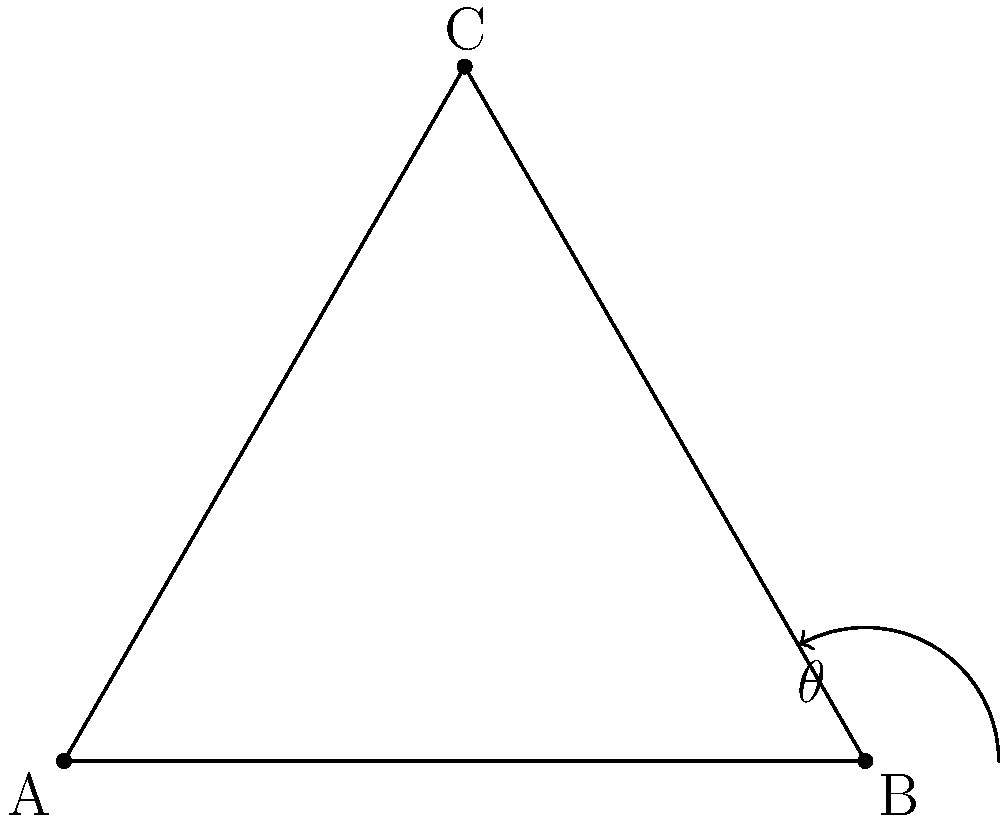In a ball-and-stick model of a protein side chain, you are measuring the bond angle between three atoms: A, B, and C. Using a protractor, you determine that the angle $\theta$ at atom B is 109.5°. What is the measurement of angle BAC in this triangle? To find the measurement of angle BAC, we can follow these steps:

1. Recall that the sum of angles in a triangle is always 180°.

2. We are given that angle ABC (θ) is 109.5°.

3. Let's denote the unknown angle BAC as x.

4. The third angle (BCA) will be 180° - 109.5° - x.

5. We can set up the equation:
   $x + 109.5° + (180° - 109.5° - x) = 180°$

6. Simplify:
   $x + 109.5° + 70.5° - x = 180°$

7. Cancel out x terms:
   $109.5° + 70.5° = 180°$

8. This equation is true, confirming our setup is correct.

9. To find x (angle BAC), we can use:
   $x + 109.5° + 70.5° = 180°$
   $x + 180° = 180°$
   $x = 0°$

Therefore, the measurement of angle BAC is 0°.
Answer: 0° 